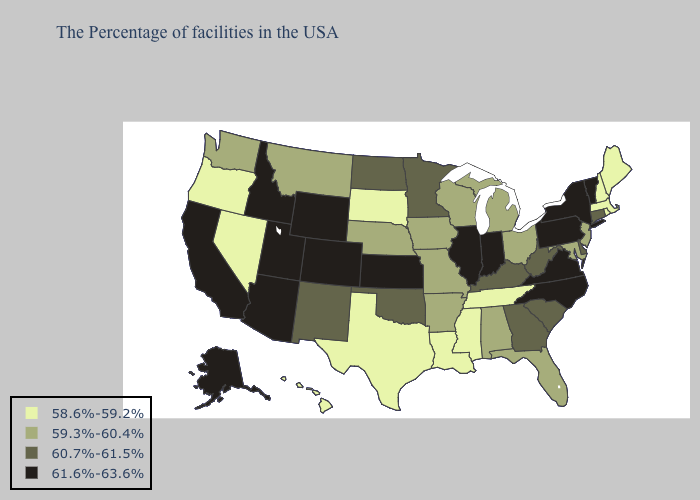Name the states that have a value in the range 58.6%-59.2%?
Write a very short answer. Maine, Massachusetts, Rhode Island, New Hampshire, Tennessee, Mississippi, Louisiana, Texas, South Dakota, Nevada, Oregon, Hawaii. Does Idaho have the highest value in the West?
Give a very brief answer. Yes. Does Oregon have the highest value in the West?
Short answer required. No. What is the value of Missouri?
Quick response, please. 59.3%-60.4%. Which states have the highest value in the USA?
Give a very brief answer. Vermont, New York, Pennsylvania, Virginia, North Carolina, Indiana, Illinois, Kansas, Wyoming, Colorado, Utah, Arizona, Idaho, California, Alaska. Among the states that border Connecticut , does Massachusetts have the lowest value?
Be succinct. Yes. Among the states that border Connecticut , does New York have the highest value?
Quick response, please. Yes. What is the value of Texas?
Short answer required. 58.6%-59.2%. Is the legend a continuous bar?
Concise answer only. No. What is the lowest value in states that border Montana?
Keep it brief. 58.6%-59.2%. Name the states that have a value in the range 58.6%-59.2%?
Keep it brief. Maine, Massachusetts, Rhode Island, New Hampshire, Tennessee, Mississippi, Louisiana, Texas, South Dakota, Nevada, Oregon, Hawaii. Does the first symbol in the legend represent the smallest category?
Be succinct. Yes. What is the highest value in the MidWest ?
Give a very brief answer. 61.6%-63.6%. What is the lowest value in states that border Kentucky?
Write a very short answer. 58.6%-59.2%. Does the first symbol in the legend represent the smallest category?
Be succinct. Yes. 